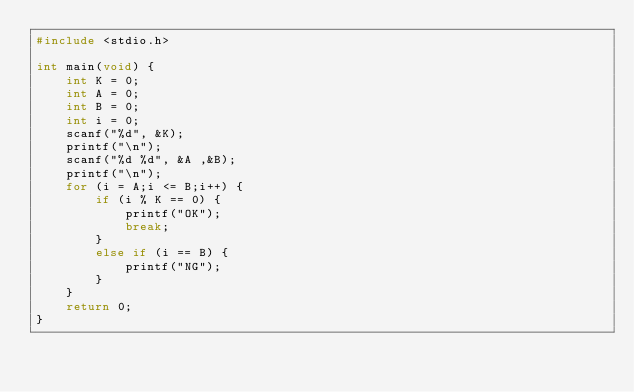<code> <loc_0><loc_0><loc_500><loc_500><_C_>#include <stdio.h>

int main(void) {
    int K = 0;
    int A = 0;
    int B = 0;
    int i = 0;
    scanf("%d", &K);
    printf("\n");
    scanf("%d %d", &A ,&B);
    printf("\n");
    for (i = A;i <= B;i++) {
        if (i % K == 0) {
            printf("OK");
            break;
        }
        else if (i == B) {
            printf("NG");
        }
    }
    return 0;
}</code> 